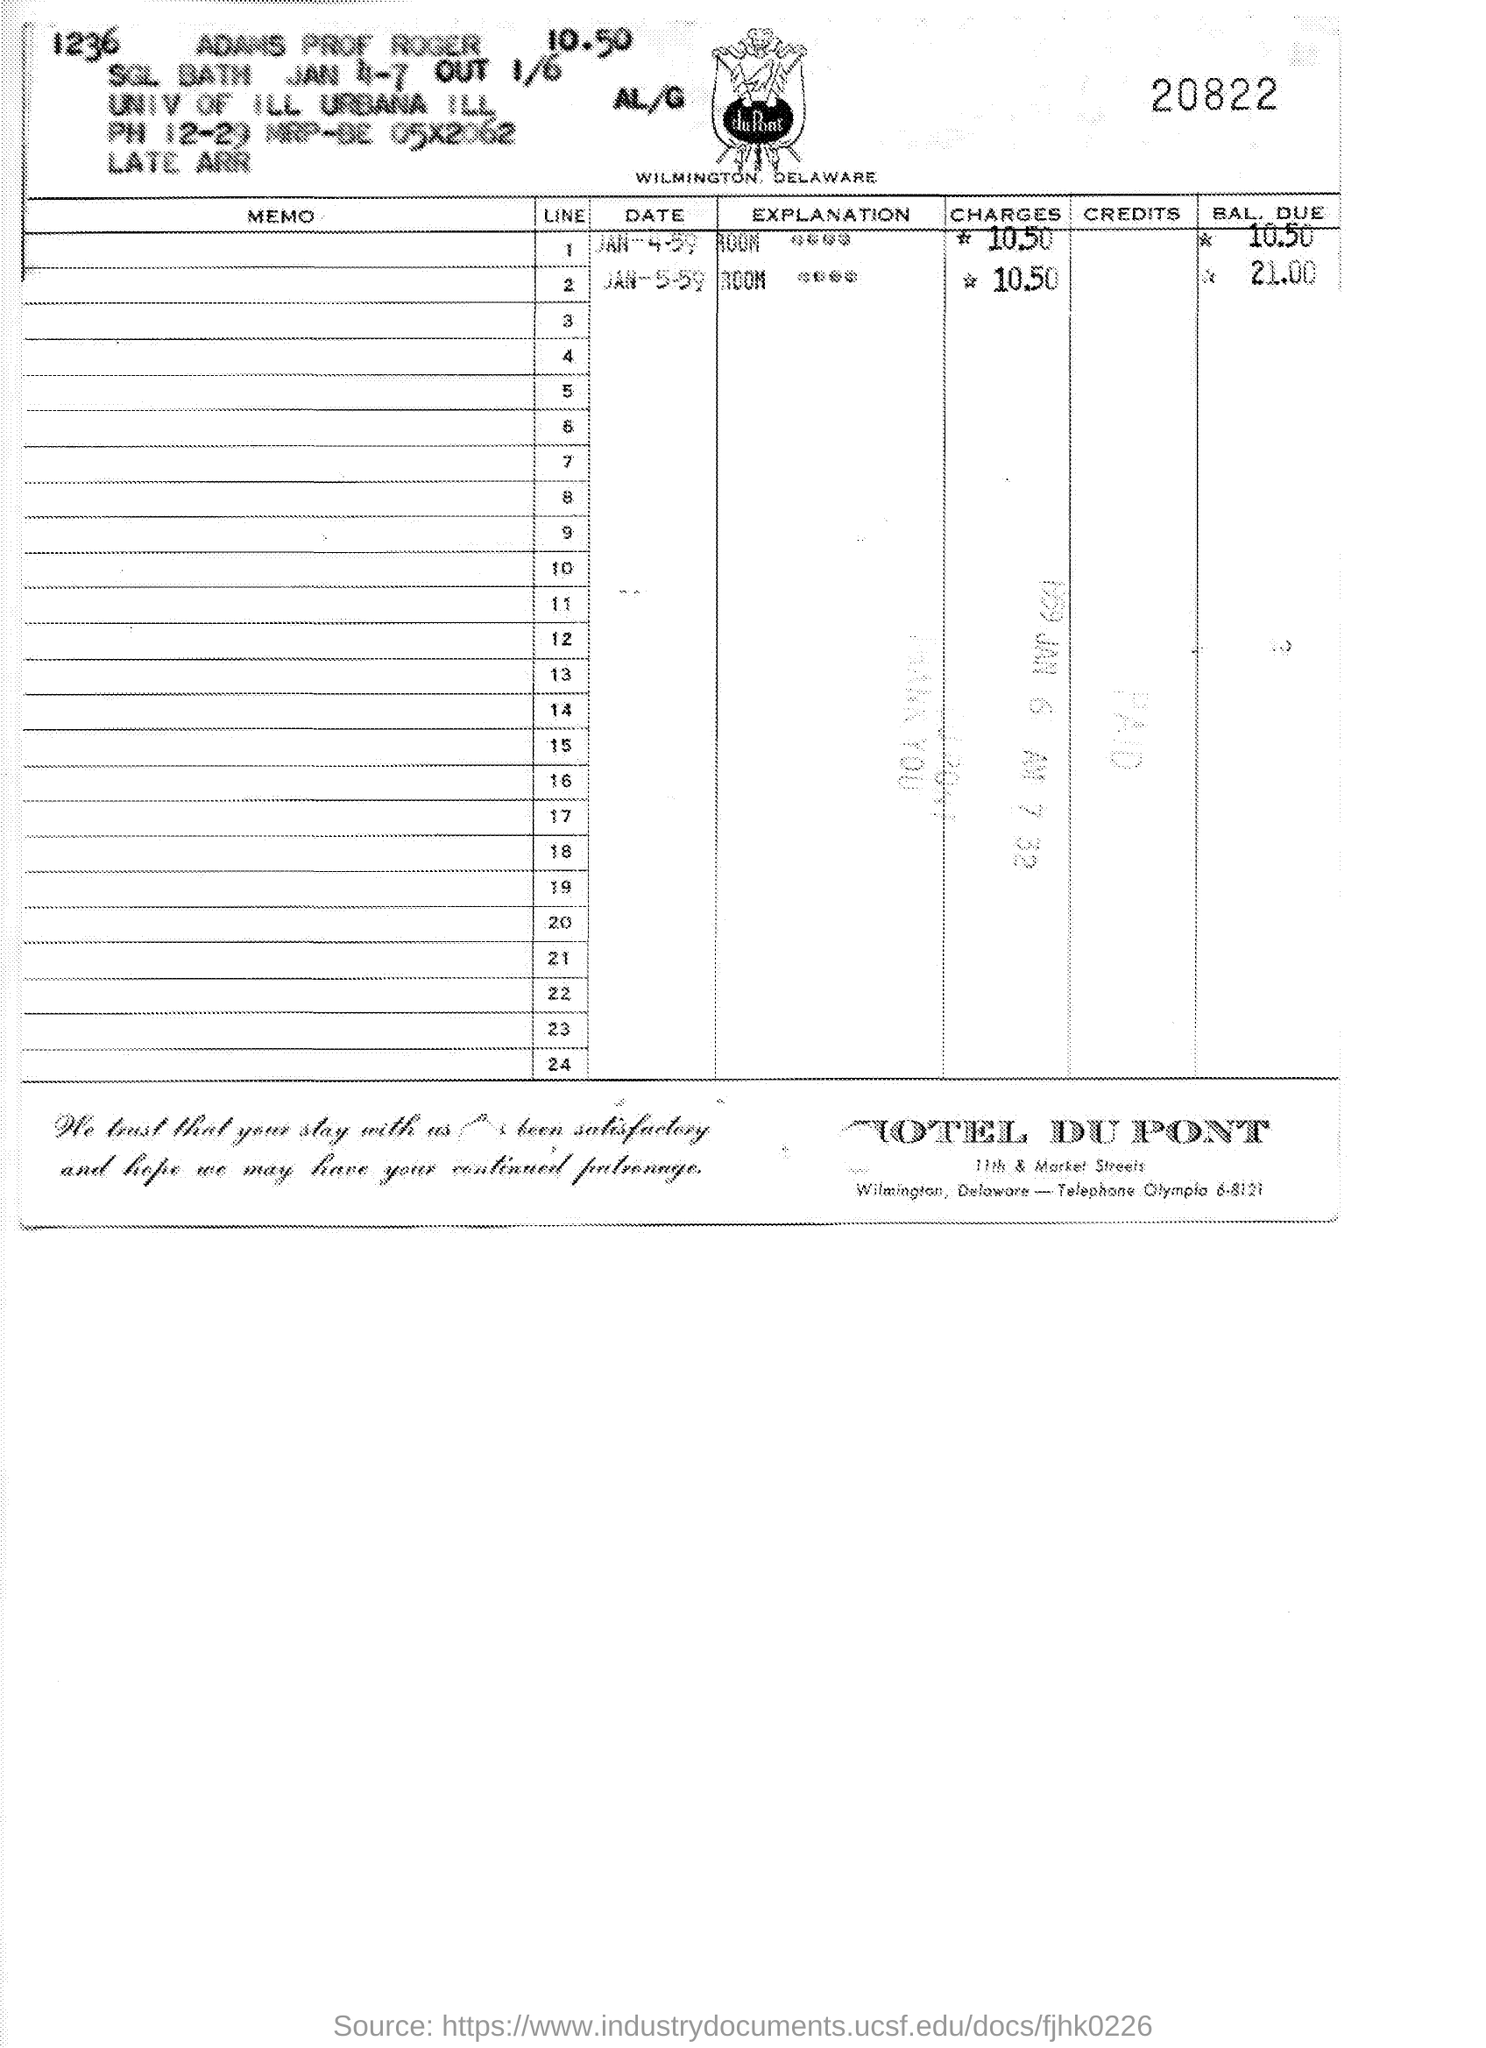Point out several critical features in this image. The hotel mentioned is HOTEL DU PONT. The number written at the top right of the page is 20822... On January 5, 1959, the balance due is $21.00. 